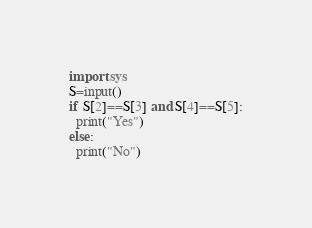Convert code to text. <code><loc_0><loc_0><loc_500><loc_500><_Python_>import sys
S=input()
if S[2]==S[3] and S[4]==S[5]:
  print("Yes")
else:
  print("No")</code> 